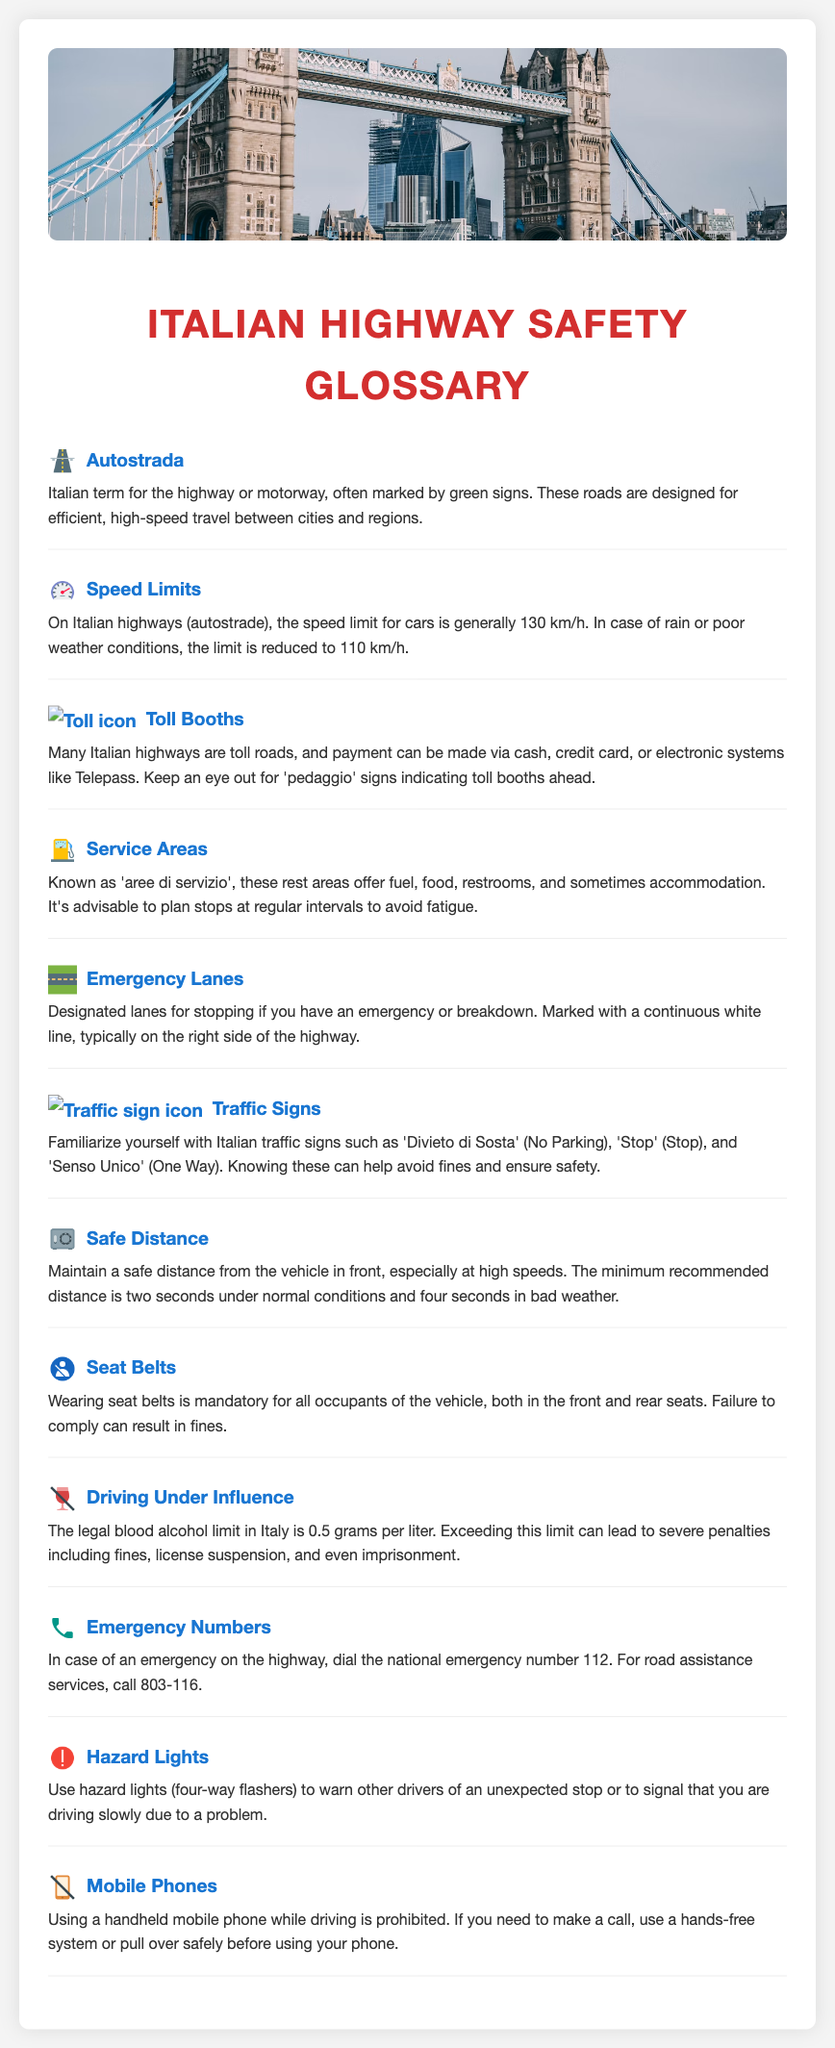what is the speed limit for cars on Italian highways? The speed limit for cars on Italian highways is generally 130 km/h.
Answer: 130 km/h what is the legal blood alcohol limit in Italy? The legal blood alcohol limit in Italy is 0.5 grams per liter.
Answer: 0.5 grams per liter what is the Italian term for highway? The Italian term for highway is Autostrada.
Answer: Autostrada how should you use hazard lights? Hazard lights should be used to warn other drivers of an unexpected stop or to signal slow driving due to a problem.
Answer: To warn other drivers what is recommended for maintaining safe distance in normal conditions? The recommended minimum distance is two seconds in normal conditions.
Answer: Two seconds what payment methods are available at toll booths? Payment can be made via cash, credit card, or electronic systems like Telepass.
Answer: Cash, credit card, Telepass what should you do in case of an emergency on the highway? In case of an emergency on the highway, dial the national emergency number 112.
Answer: Dial 112 what must all occupants of the vehicle wear? All occupants of the vehicle must wear seat belts.
Answer: Seat belts 